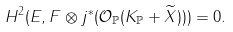Convert formula to latex. <formula><loc_0><loc_0><loc_500><loc_500>H ^ { 2 } ( E , F \otimes j ^ { * } ( \mathcal { O } _ { \mathbb { P } } ( K _ { \mathbb { P } } + \widetilde { X } ) ) ) = 0 .</formula> 